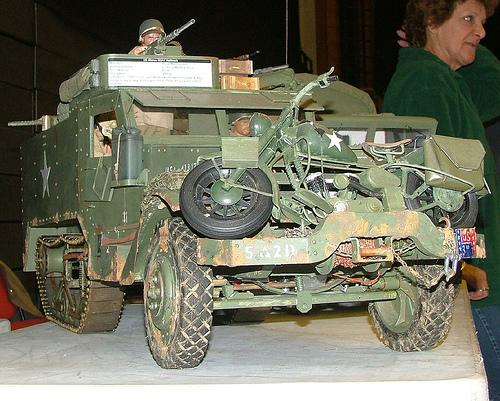Provide a sentiment analysis for the image, focusing on the overall feeling and atmosphere. The overall sentiment in the image is energetic and playful, with a strong sense of fun and adventure as people interact with the toy army scene. Evaluate the image's quality, including details like clarity and composition. The image has a high quality with clear details, vibrant colors, and an engaging composition that showcases various elements and interactions within the toy army scene. Describe the woman's appearance and her relationship with the surrounding environment. The woman has curly brown hair, wears a green shirt and blue jeans, stands near the tank, and interacts with the overall toy army setup, appearing as a protagonist in the scene. Analyze the roles and interactions of the human figures in the image. The humans in the scene include a man aiming a gun, a man inside the tanker, a woman standing beside it, and another soldier statue pointing a rifle. They seem to be a part of the toy scene, creating an immersive experience. Count the number of wheels visible in the image and specify which objects they belong to. There are 9 wheels: 3 wheels on the toy tank, 2 wheels on the toy motorcycle, and 4 wheels on the military jeep. Identify the primary object in the image and describe its surrounding environment. The primary object is a green toy army tanker, surrounded by various other elements including soldiers, a woman, a motorcycle, and jeep. Identify any notable accessories or clothing items worn by the human figures in this image. Notable items include a green hat, a gold-colored bracelet, a green sweater, and a green helmet on various human figures in the image. Construct a critical reasoning scenario based on the image presented, including the primary object and its purpose. The green toy army world is a detailed and realistic recreation in which various characters and vehicles aim to replicate a military operation. The primary purpose seems to be to provide a sense of adventure and excitement through the power of imagination and storytelling. Examine the image for any hidden or less obvious objects and describe what you find. A less obvious object is an army five-gallon fuel can located near the toy motorcycle, providing a sense of realism and practicality to the toy world. Explain the scenario unfolding in the image with emphasis on human figures. Several people are interacting with a toy army scene that includes a tank, a jeep, a motorcycle, and several soldiers holding different positions and weaponry. 